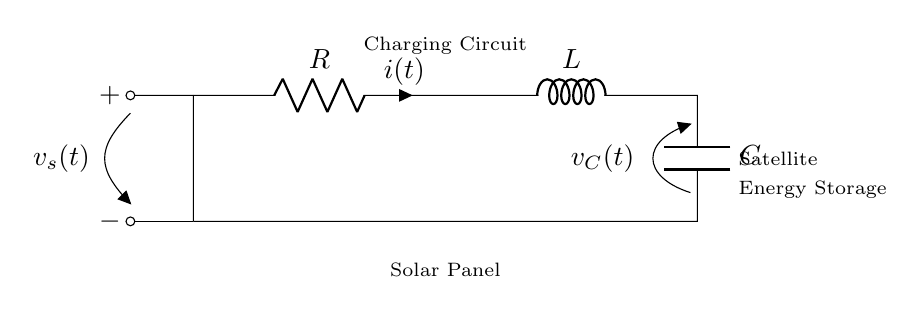What are the components in the circuit? The circuit contains a resistor, an inductor, and a capacitor which are connected in series. A battery is indicated for supplying voltage.
Answer: Resistor, inductor, capacitor What does the symbol 'i(t)' represent? The symbol 'i(t)' represents the current flowing through the resistor at time 't'. It is a function of time, indicating how current changes.
Answer: Current What is the role of the solar panel in this circuit? The solar panel is being used to charge the energy storage system through the circuit. It converts sunlight into electrical energy that is stored.
Answer: Charging energy storage How does the capacitor behave during the charge cycle? During the charge cycle, the capacitor accumulates charge until it reaches its maximum voltage (voltage across the capacitor). This occurs over time as current flows in.
Answer: Accumulates charge What is the function of the resistor in this circuit? The resistor limits the current flow in the circuit, which helps manage the charge and discharge rates of the capacitor and inductor. It controls energy dissipation.
Answer: Limits current What happens to the voltage 'v_C(t)' across the capacitor when it is fully charged? When the capacitor is fully charged, the voltage 'v_C(t)' reaches its maximum value and stabilizes, meaning no more current flows into the capacitor from the supply.
Answer: Stabilizes at maximum value How does the combination of R, L, and C affect the overall behavior of the circuit? The combination of resistor, inductor, and capacitor creates a damped harmonic oscillator which influences the charge and discharge cycles, affecting oscillation and energy transfer rates.
Answer: Damped harmonic oscillator 